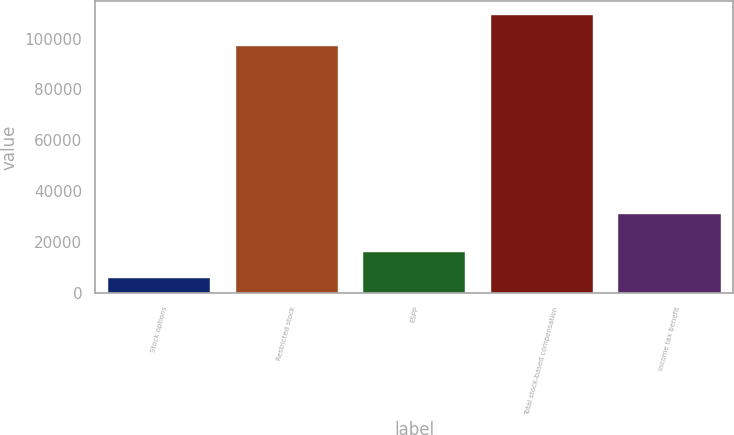Convert chart. <chart><loc_0><loc_0><loc_500><loc_500><bar_chart><fcel>Stock options<fcel>Restricted stock<fcel>ESPP<fcel>Total stock-based compensation<fcel>Income tax benefit<nl><fcel>5649<fcel>96989<fcel>16005.8<fcel>109217<fcel>30980<nl></chart> 